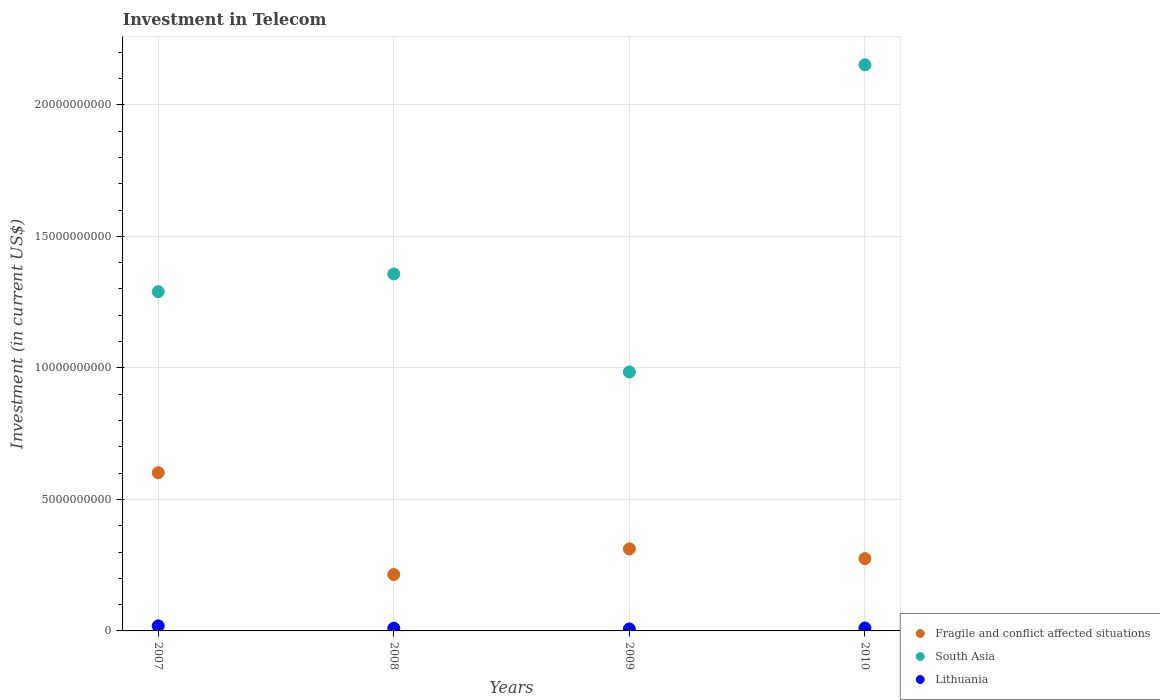How many different coloured dotlines are there?
Ensure brevity in your answer.  3. Is the number of dotlines equal to the number of legend labels?
Your answer should be compact. Yes. What is the amount invested in telecom in Fragile and conflict affected situations in 2009?
Keep it short and to the point. 3.12e+09. Across all years, what is the maximum amount invested in telecom in South Asia?
Give a very brief answer. 2.15e+1. Across all years, what is the minimum amount invested in telecom in Lithuania?
Give a very brief answer. 7.50e+07. In which year was the amount invested in telecom in Lithuania maximum?
Offer a very short reply. 2007. In which year was the amount invested in telecom in Lithuania minimum?
Keep it short and to the point. 2009. What is the total amount invested in telecom in Lithuania in the graph?
Provide a short and direct response. 4.83e+08. What is the difference between the amount invested in telecom in South Asia in 2007 and that in 2008?
Your response must be concise. -6.73e+08. What is the difference between the amount invested in telecom in Lithuania in 2009 and the amount invested in telecom in Fragile and conflict affected situations in 2010?
Provide a succinct answer. -2.67e+09. What is the average amount invested in telecom in South Asia per year?
Provide a succinct answer. 1.45e+1. In the year 2010, what is the difference between the amount invested in telecom in Fragile and conflict affected situations and amount invested in telecom in Lithuania?
Provide a succinct answer. 2.64e+09. What is the ratio of the amount invested in telecom in Lithuania in 2008 to that in 2009?
Make the answer very short. 1.37. Is the amount invested in telecom in Fragile and conflict affected situations in 2008 less than that in 2009?
Your response must be concise. Yes. Is the difference between the amount invested in telecom in Fragile and conflict affected situations in 2009 and 2010 greater than the difference between the amount invested in telecom in Lithuania in 2009 and 2010?
Ensure brevity in your answer.  Yes. What is the difference between the highest and the second highest amount invested in telecom in Fragile and conflict affected situations?
Make the answer very short. 2.90e+09. What is the difference between the highest and the lowest amount invested in telecom in Lithuania?
Your answer should be compact. 1.18e+08. Is the amount invested in telecom in South Asia strictly greater than the amount invested in telecom in Lithuania over the years?
Provide a succinct answer. Yes. How many dotlines are there?
Offer a very short reply. 3. What is the difference between two consecutive major ticks on the Y-axis?
Offer a terse response. 5.00e+09. Does the graph contain any zero values?
Ensure brevity in your answer.  No. What is the title of the graph?
Your answer should be compact. Investment in Telecom. Does "European Union" appear as one of the legend labels in the graph?
Keep it short and to the point. No. What is the label or title of the Y-axis?
Offer a very short reply. Investment (in current US$). What is the Investment (in current US$) in Fragile and conflict affected situations in 2007?
Provide a succinct answer. 6.01e+09. What is the Investment (in current US$) in South Asia in 2007?
Provide a short and direct response. 1.29e+1. What is the Investment (in current US$) in Lithuania in 2007?
Make the answer very short. 1.93e+08. What is the Investment (in current US$) in Fragile and conflict affected situations in 2008?
Your answer should be compact. 2.14e+09. What is the Investment (in current US$) in South Asia in 2008?
Keep it short and to the point. 1.36e+1. What is the Investment (in current US$) of Lithuania in 2008?
Give a very brief answer. 1.03e+08. What is the Investment (in current US$) in Fragile and conflict affected situations in 2009?
Ensure brevity in your answer.  3.12e+09. What is the Investment (in current US$) of South Asia in 2009?
Provide a succinct answer. 9.84e+09. What is the Investment (in current US$) of Lithuania in 2009?
Your response must be concise. 7.50e+07. What is the Investment (in current US$) of Fragile and conflict affected situations in 2010?
Provide a succinct answer. 2.75e+09. What is the Investment (in current US$) of South Asia in 2010?
Provide a succinct answer. 2.15e+1. What is the Investment (in current US$) in Lithuania in 2010?
Your answer should be very brief. 1.12e+08. Across all years, what is the maximum Investment (in current US$) in Fragile and conflict affected situations?
Make the answer very short. 6.01e+09. Across all years, what is the maximum Investment (in current US$) of South Asia?
Offer a very short reply. 2.15e+1. Across all years, what is the maximum Investment (in current US$) of Lithuania?
Keep it short and to the point. 1.93e+08. Across all years, what is the minimum Investment (in current US$) of Fragile and conflict affected situations?
Ensure brevity in your answer.  2.14e+09. Across all years, what is the minimum Investment (in current US$) in South Asia?
Provide a succinct answer. 9.84e+09. Across all years, what is the minimum Investment (in current US$) of Lithuania?
Ensure brevity in your answer.  7.50e+07. What is the total Investment (in current US$) of Fragile and conflict affected situations in the graph?
Ensure brevity in your answer.  1.40e+1. What is the total Investment (in current US$) of South Asia in the graph?
Your answer should be compact. 5.78e+1. What is the total Investment (in current US$) of Lithuania in the graph?
Your answer should be very brief. 4.83e+08. What is the difference between the Investment (in current US$) in Fragile and conflict affected situations in 2007 and that in 2008?
Your answer should be very brief. 3.87e+09. What is the difference between the Investment (in current US$) in South Asia in 2007 and that in 2008?
Offer a terse response. -6.73e+08. What is the difference between the Investment (in current US$) of Lithuania in 2007 and that in 2008?
Provide a short and direct response. 9.02e+07. What is the difference between the Investment (in current US$) in Fragile and conflict affected situations in 2007 and that in 2009?
Give a very brief answer. 2.90e+09. What is the difference between the Investment (in current US$) in South Asia in 2007 and that in 2009?
Provide a succinct answer. 3.05e+09. What is the difference between the Investment (in current US$) of Lithuania in 2007 and that in 2009?
Ensure brevity in your answer.  1.18e+08. What is the difference between the Investment (in current US$) in Fragile and conflict affected situations in 2007 and that in 2010?
Your answer should be very brief. 3.27e+09. What is the difference between the Investment (in current US$) in South Asia in 2007 and that in 2010?
Make the answer very short. -8.62e+09. What is the difference between the Investment (in current US$) in Lithuania in 2007 and that in 2010?
Keep it short and to the point. 8.15e+07. What is the difference between the Investment (in current US$) in Fragile and conflict affected situations in 2008 and that in 2009?
Keep it short and to the point. -9.76e+08. What is the difference between the Investment (in current US$) in South Asia in 2008 and that in 2009?
Ensure brevity in your answer.  3.73e+09. What is the difference between the Investment (in current US$) in Lithuania in 2008 and that in 2009?
Provide a succinct answer. 2.80e+07. What is the difference between the Investment (in current US$) of Fragile and conflict affected situations in 2008 and that in 2010?
Keep it short and to the point. -6.05e+08. What is the difference between the Investment (in current US$) in South Asia in 2008 and that in 2010?
Make the answer very short. -7.95e+09. What is the difference between the Investment (in current US$) of Lithuania in 2008 and that in 2010?
Provide a short and direct response. -8.70e+06. What is the difference between the Investment (in current US$) in Fragile and conflict affected situations in 2009 and that in 2010?
Offer a very short reply. 3.71e+08. What is the difference between the Investment (in current US$) of South Asia in 2009 and that in 2010?
Your response must be concise. -1.17e+1. What is the difference between the Investment (in current US$) of Lithuania in 2009 and that in 2010?
Keep it short and to the point. -3.67e+07. What is the difference between the Investment (in current US$) of Fragile and conflict affected situations in 2007 and the Investment (in current US$) of South Asia in 2008?
Your answer should be compact. -7.56e+09. What is the difference between the Investment (in current US$) in Fragile and conflict affected situations in 2007 and the Investment (in current US$) in Lithuania in 2008?
Give a very brief answer. 5.91e+09. What is the difference between the Investment (in current US$) in South Asia in 2007 and the Investment (in current US$) in Lithuania in 2008?
Your response must be concise. 1.28e+1. What is the difference between the Investment (in current US$) in Fragile and conflict affected situations in 2007 and the Investment (in current US$) in South Asia in 2009?
Your response must be concise. -3.83e+09. What is the difference between the Investment (in current US$) of Fragile and conflict affected situations in 2007 and the Investment (in current US$) of Lithuania in 2009?
Offer a very short reply. 5.94e+09. What is the difference between the Investment (in current US$) in South Asia in 2007 and the Investment (in current US$) in Lithuania in 2009?
Give a very brief answer. 1.28e+1. What is the difference between the Investment (in current US$) in Fragile and conflict affected situations in 2007 and the Investment (in current US$) in South Asia in 2010?
Provide a short and direct response. -1.55e+1. What is the difference between the Investment (in current US$) in Fragile and conflict affected situations in 2007 and the Investment (in current US$) in Lithuania in 2010?
Your response must be concise. 5.90e+09. What is the difference between the Investment (in current US$) of South Asia in 2007 and the Investment (in current US$) of Lithuania in 2010?
Offer a very short reply. 1.28e+1. What is the difference between the Investment (in current US$) in Fragile and conflict affected situations in 2008 and the Investment (in current US$) in South Asia in 2009?
Provide a short and direct response. -7.70e+09. What is the difference between the Investment (in current US$) of Fragile and conflict affected situations in 2008 and the Investment (in current US$) of Lithuania in 2009?
Keep it short and to the point. 2.07e+09. What is the difference between the Investment (in current US$) of South Asia in 2008 and the Investment (in current US$) of Lithuania in 2009?
Ensure brevity in your answer.  1.35e+1. What is the difference between the Investment (in current US$) of Fragile and conflict affected situations in 2008 and the Investment (in current US$) of South Asia in 2010?
Your answer should be very brief. -1.94e+1. What is the difference between the Investment (in current US$) in Fragile and conflict affected situations in 2008 and the Investment (in current US$) in Lithuania in 2010?
Ensure brevity in your answer.  2.03e+09. What is the difference between the Investment (in current US$) of South Asia in 2008 and the Investment (in current US$) of Lithuania in 2010?
Ensure brevity in your answer.  1.35e+1. What is the difference between the Investment (in current US$) in Fragile and conflict affected situations in 2009 and the Investment (in current US$) in South Asia in 2010?
Keep it short and to the point. -1.84e+1. What is the difference between the Investment (in current US$) in Fragile and conflict affected situations in 2009 and the Investment (in current US$) in Lithuania in 2010?
Make the answer very short. 3.01e+09. What is the difference between the Investment (in current US$) of South Asia in 2009 and the Investment (in current US$) of Lithuania in 2010?
Your answer should be compact. 9.73e+09. What is the average Investment (in current US$) in Fragile and conflict affected situations per year?
Ensure brevity in your answer.  3.51e+09. What is the average Investment (in current US$) of South Asia per year?
Offer a terse response. 1.45e+1. What is the average Investment (in current US$) in Lithuania per year?
Your answer should be compact. 1.21e+08. In the year 2007, what is the difference between the Investment (in current US$) of Fragile and conflict affected situations and Investment (in current US$) of South Asia?
Offer a terse response. -6.88e+09. In the year 2007, what is the difference between the Investment (in current US$) in Fragile and conflict affected situations and Investment (in current US$) in Lithuania?
Provide a short and direct response. 5.82e+09. In the year 2007, what is the difference between the Investment (in current US$) in South Asia and Investment (in current US$) in Lithuania?
Your answer should be very brief. 1.27e+1. In the year 2008, what is the difference between the Investment (in current US$) in Fragile and conflict affected situations and Investment (in current US$) in South Asia?
Keep it short and to the point. -1.14e+1. In the year 2008, what is the difference between the Investment (in current US$) of Fragile and conflict affected situations and Investment (in current US$) of Lithuania?
Make the answer very short. 2.04e+09. In the year 2008, what is the difference between the Investment (in current US$) of South Asia and Investment (in current US$) of Lithuania?
Provide a short and direct response. 1.35e+1. In the year 2009, what is the difference between the Investment (in current US$) of Fragile and conflict affected situations and Investment (in current US$) of South Asia?
Your answer should be compact. -6.72e+09. In the year 2009, what is the difference between the Investment (in current US$) in Fragile and conflict affected situations and Investment (in current US$) in Lithuania?
Make the answer very short. 3.04e+09. In the year 2009, what is the difference between the Investment (in current US$) in South Asia and Investment (in current US$) in Lithuania?
Offer a very short reply. 9.77e+09. In the year 2010, what is the difference between the Investment (in current US$) in Fragile and conflict affected situations and Investment (in current US$) in South Asia?
Make the answer very short. -1.88e+1. In the year 2010, what is the difference between the Investment (in current US$) of Fragile and conflict affected situations and Investment (in current US$) of Lithuania?
Your answer should be very brief. 2.64e+09. In the year 2010, what is the difference between the Investment (in current US$) in South Asia and Investment (in current US$) in Lithuania?
Provide a short and direct response. 2.14e+1. What is the ratio of the Investment (in current US$) in Fragile and conflict affected situations in 2007 to that in 2008?
Give a very brief answer. 2.81. What is the ratio of the Investment (in current US$) in South Asia in 2007 to that in 2008?
Your answer should be compact. 0.95. What is the ratio of the Investment (in current US$) in Lithuania in 2007 to that in 2008?
Offer a very short reply. 1.88. What is the ratio of the Investment (in current US$) in Fragile and conflict affected situations in 2007 to that in 2009?
Your response must be concise. 1.93. What is the ratio of the Investment (in current US$) of South Asia in 2007 to that in 2009?
Make the answer very short. 1.31. What is the ratio of the Investment (in current US$) of Lithuania in 2007 to that in 2009?
Keep it short and to the point. 2.58. What is the ratio of the Investment (in current US$) in Fragile and conflict affected situations in 2007 to that in 2010?
Make the answer very short. 2.19. What is the ratio of the Investment (in current US$) of South Asia in 2007 to that in 2010?
Your response must be concise. 0.6. What is the ratio of the Investment (in current US$) of Lithuania in 2007 to that in 2010?
Ensure brevity in your answer.  1.73. What is the ratio of the Investment (in current US$) in Fragile and conflict affected situations in 2008 to that in 2009?
Offer a terse response. 0.69. What is the ratio of the Investment (in current US$) of South Asia in 2008 to that in 2009?
Provide a short and direct response. 1.38. What is the ratio of the Investment (in current US$) of Lithuania in 2008 to that in 2009?
Give a very brief answer. 1.37. What is the ratio of the Investment (in current US$) in Fragile and conflict affected situations in 2008 to that in 2010?
Provide a succinct answer. 0.78. What is the ratio of the Investment (in current US$) of South Asia in 2008 to that in 2010?
Make the answer very short. 0.63. What is the ratio of the Investment (in current US$) in Lithuania in 2008 to that in 2010?
Your answer should be compact. 0.92. What is the ratio of the Investment (in current US$) of Fragile and conflict affected situations in 2009 to that in 2010?
Offer a very short reply. 1.13. What is the ratio of the Investment (in current US$) of South Asia in 2009 to that in 2010?
Your answer should be very brief. 0.46. What is the ratio of the Investment (in current US$) of Lithuania in 2009 to that in 2010?
Make the answer very short. 0.67. What is the difference between the highest and the second highest Investment (in current US$) of Fragile and conflict affected situations?
Make the answer very short. 2.90e+09. What is the difference between the highest and the second highest Investment (in current US$) of South Asia?
Offer a terse response. 7.95e+09. What is the difference between the highest and the second highest Investment (in current US$) of Lithuania?
Offer a very short reply. 8.15e+07. What is the difference between the highest and the lowest Investment (in current US$) in Fragile and conflict affected situations?
Your answer should be compact. 3.87e+09. What is the difference between the highest and the lowest Investment (in current US$) of South Asia?
Offer a terse response. 1.17e+1. What is the difference between the highest and the lowest Investment (in current US$) of Lithuania?
Provide a short and direct response. 1.18e+08. 